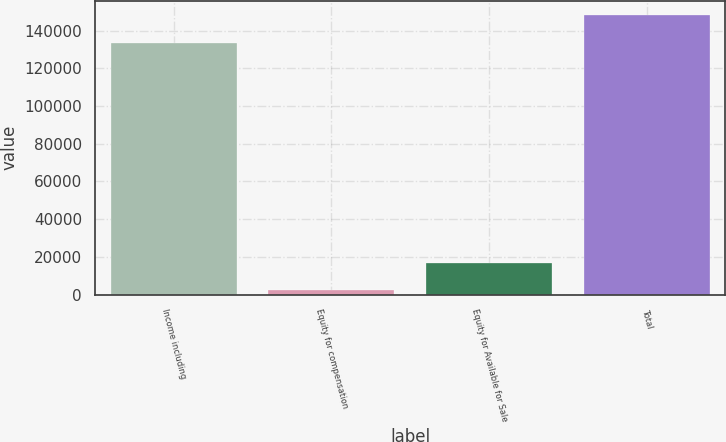Convert chart. <chart><loc_0><loc_0><loc_500><loc_500><bar_chart><fcel>Income including<fcel>Equity for compensation<fcel>Equity for Available for Sale<fcel>Total<nl><fcel>133625<fcel>2280<fcel>17020<fcel>148365<nl></chart> 